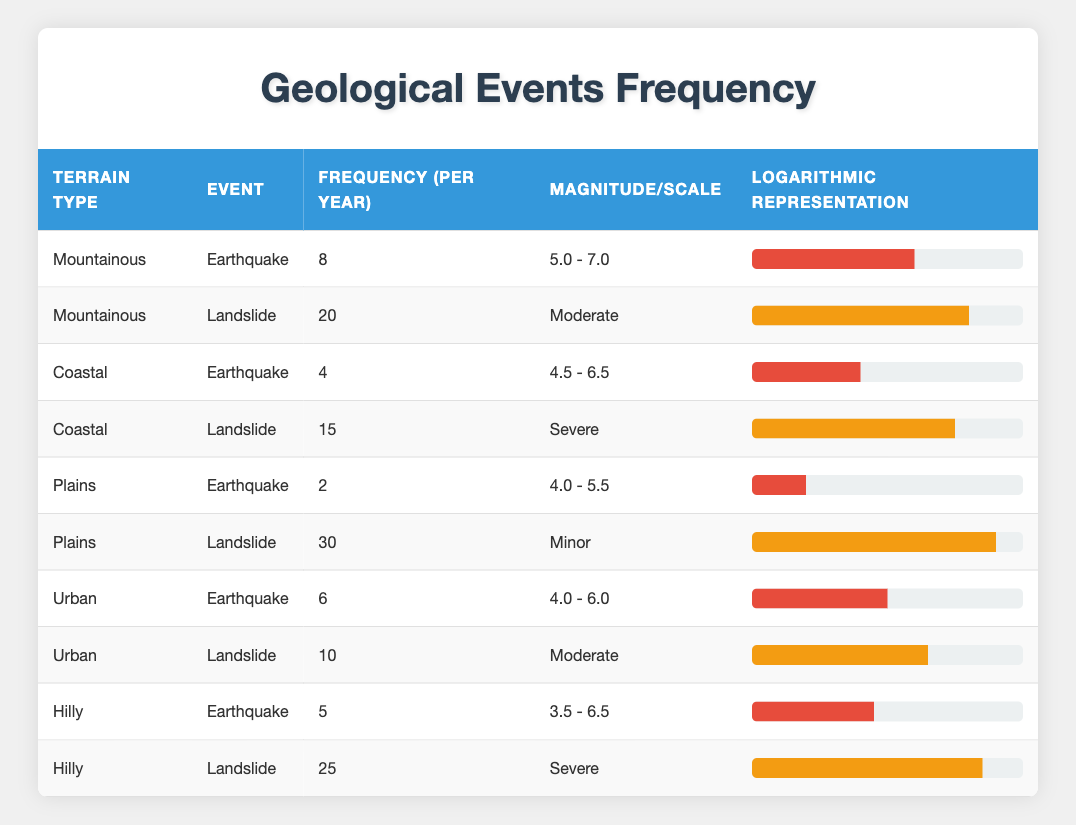What is the frequency of earthquakes in Coastal terrain? According to the table, the frequency of earthquakes in Coastal terrain is listed as 4 per year.
Answer: 4 Which terrain type has the highest frequency of landslides? The table lists Plains as having the highest frequency of landslides at 30 per year, compared to other terrain types.
Answer: Plains What is the total frequency of landslides in Mountainous and Hilly terrains combined? The frequency of landslides in Mountainous terrain is 20 per year and in Hilly terrain is 25 per year. By summing them (20 + 25), the total frequency is 45 per year.
Answer: 45 Is there any terrain type that experiences more earthquakes than Mountainous terrain? No, Mountainous terrain has the highest frequency of earthquakes at 8 per year, which is more than all other terrain types listed in the table.
Answer: No What is the average frequency of earthquakes across all terrain types? To find the average, we sum the frequencies of earthquakes (8 + 4 + 2 + 6 + 5) which equals 25, and divide by the 5 terrain types, yielding an average of 5 per year.
Answer: 5 Are landslides in Coastal terrain more frequent than in Urban terrain? Yes, Coastal terrain has 15 landslides per year, while Urban terrain has 10, confirming that Coastal terrain experiences more landslides.
Answer: Yes What is the difference in frequency of earthquakes between Mountainous and Plains terrain? Mountainous terrain experiences 8 earthquakes per year, while Plains has 2. The difference is 8 - 2 = 6 earthquakes per year.
Answer: 6 How many different scales of landslides are noted in the table? The table indicates three distinct scales for landslides: Minor, Moderate, and Severe. Therefore, there are three different scales noted.
Answer: 3 In which terrain type do both earthquakes and landslides occur with the same scale? The only terrain type where both earthquakes and landslides occur is Mountainous, with earthquakes ranging from 5.0 - 7.0 magnitude and landslides categorized as Moderate.
Answer: Mountainous 